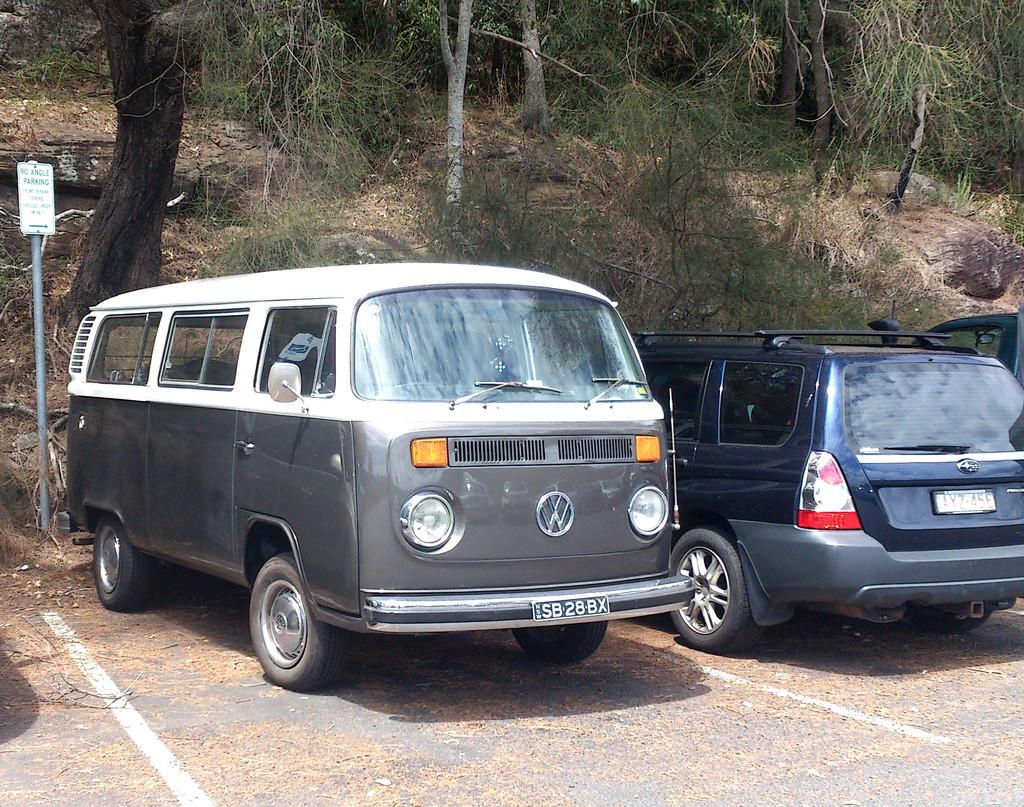What type of vehicle is in the image? There is a van in the image. Are there any other vehicles visible in the image? Yes, there are two cars on the side of the road. What can be seen in the background of the image? Trees and plants are visible on a hill in the background. What is located on the right side of the image? There is a board on the right side of the image. What type of hair can be seen on the van in the image? There is no hair present on the van in the image. What territory is being claimed by the cars on the side of the road? The image does not depict any territorial claims or disputes; it simply shows two cars parked on the side of the road. 